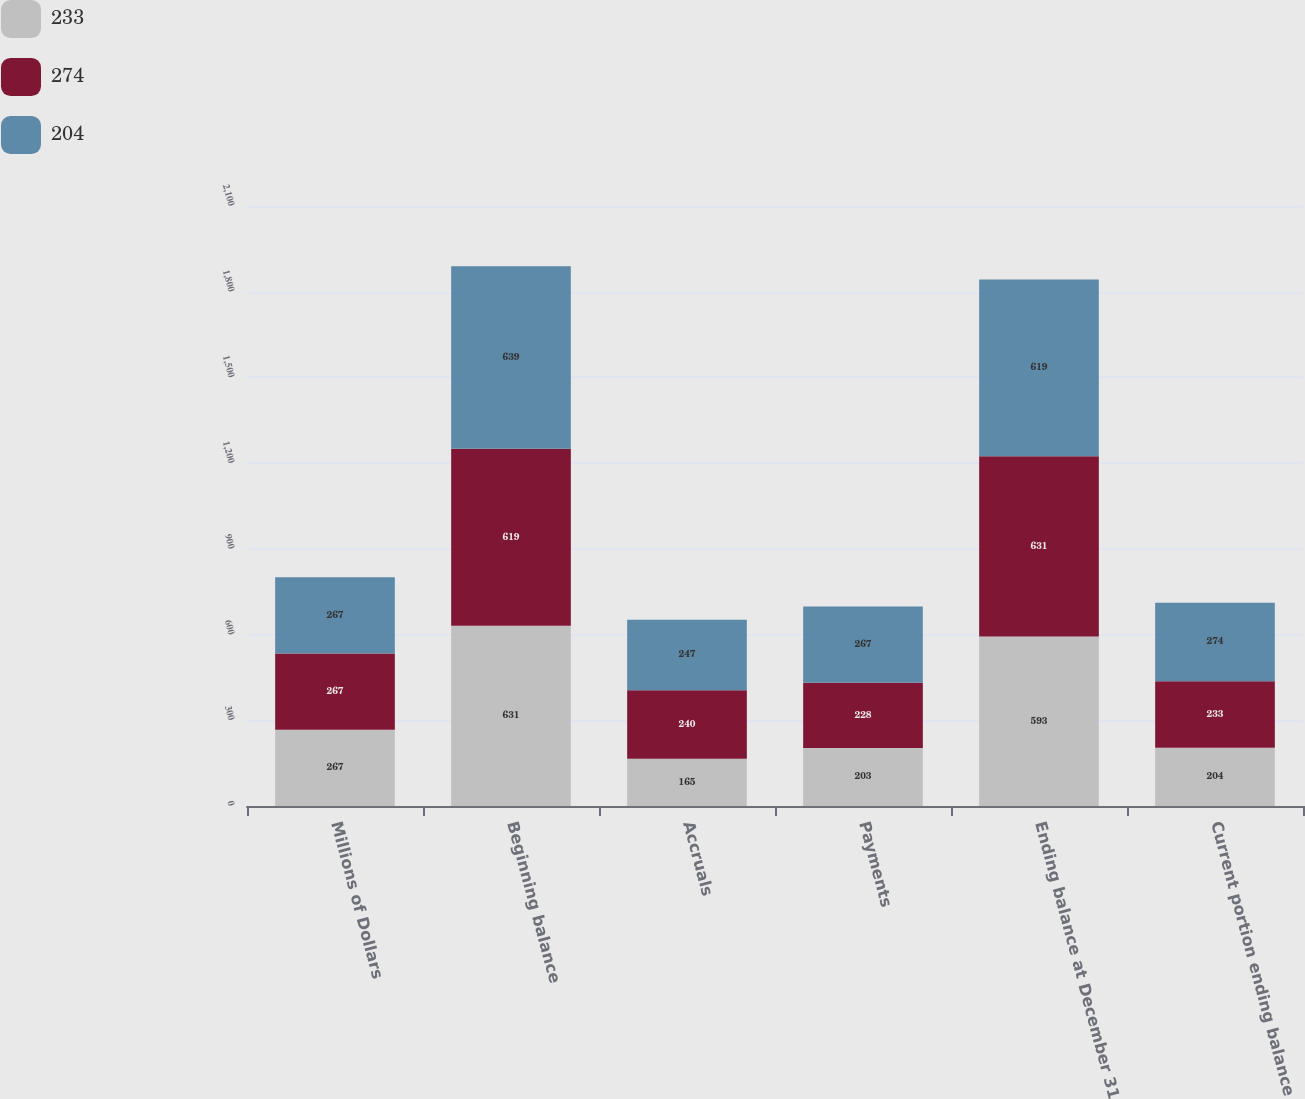<chart> <loc_0><loc_0><loc_500><loc_500><stacked_bar_chart><ecel><fcel>Millions of Dollars<fcel>Beginning balance<fcel>Accruals<fcel>Payments<fcel>Ending balance at December 31<fcel>Current portion ending balance<nl><fcel>233<fcel>267<fcel>631<fcel>165<fcel>203<fcel>593<fcel>204<nl><fcel>274<fcel>267<fcel>619<fcel>240<fcel>228<fcel>631<fcel>233<nl><fcel>204<fcel>267<fcel>639<fcel>247<fcel>267<fcel>619<fcel>274<nl></chart> 